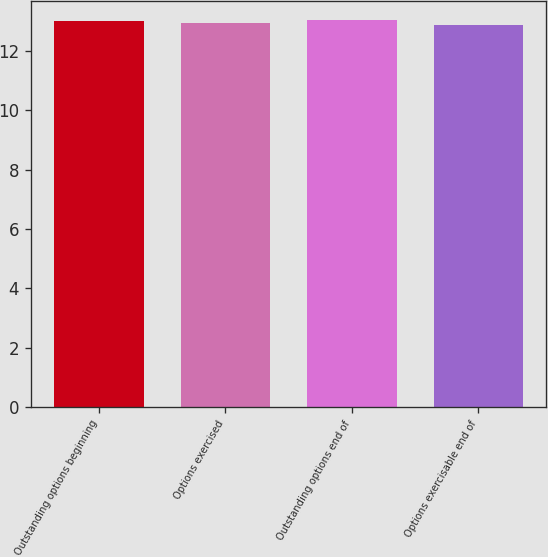Convert chart to OTSL. <chart><loc_0><loc_0><loc_500><loc_500><bar_chart><fcel>Outstanding options beginning<fcel>Options exercised<fcel>Outstanding options end of<fcel>Options exercisable end of<nl><fcel>13.01<fcel>12.93<fcel>13.03<fcel>12.87<nl></chart> 